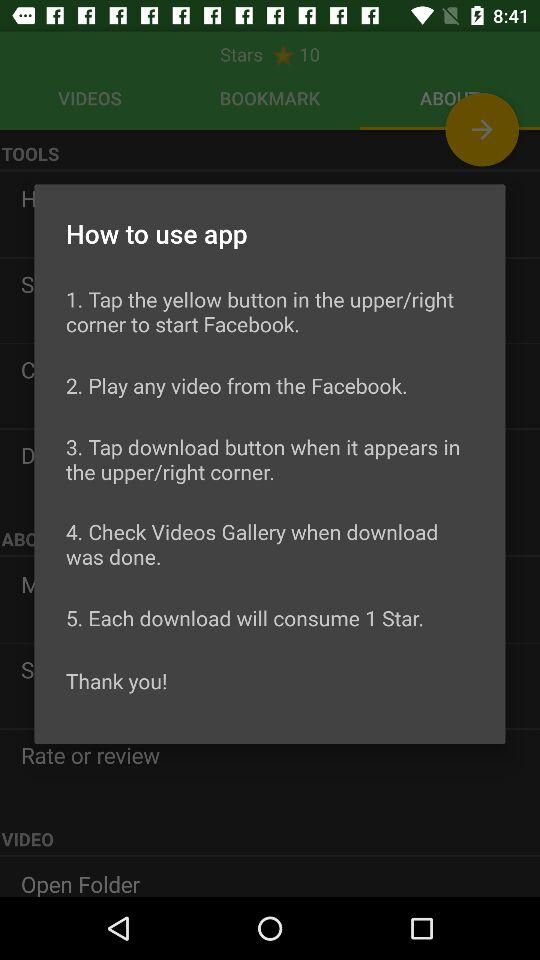How many instructions are there in the how to use section?
Answer the question using a single word or phrase. 5 